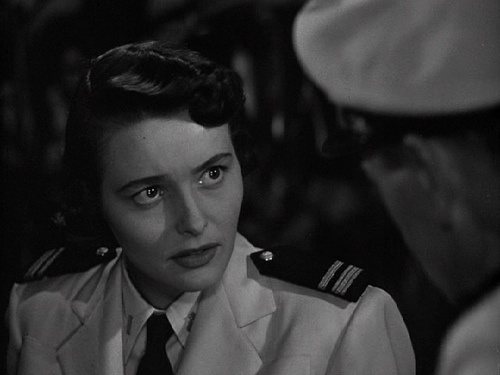Describe the objects in this image and their specific colors. I can see people in black and gray tones, people in black and gray tones, and tie in black and gray tones in this image. 